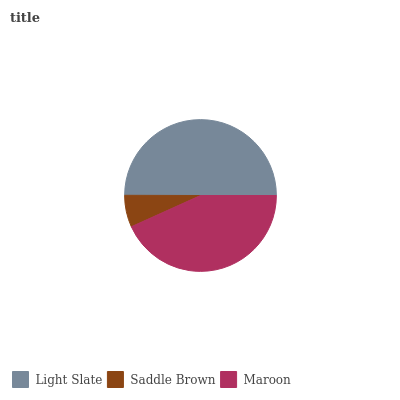Is Saddle Brown the minimum?
Answer yes or no. Yes. Is Light Slate the maximum?
Answer yes or no. Yes. Is Maroon the minimum?
Answer yes or no. No. Is Maroon the maximum?
Answer yes or no. No. Is Maroon greater than Saddle Brown?
Answer yes or no. Yes. Is Saddle Brown less than Maroon?
Answer yes or no. Yes. Is Saddle Brown greater than Maroon?
Answer yes or no. No. Is Maroon less than Saddle Brown?
Answer yes or no. No. Is Maroon the high median?
Answer yes or no. Yes. Is Maroon the low median?
Answer yes or no. Yes. Is Saddle Brown the high median?
Answer yes or no. No. Is Light Slate the low median?
Answer yes or no. No. 